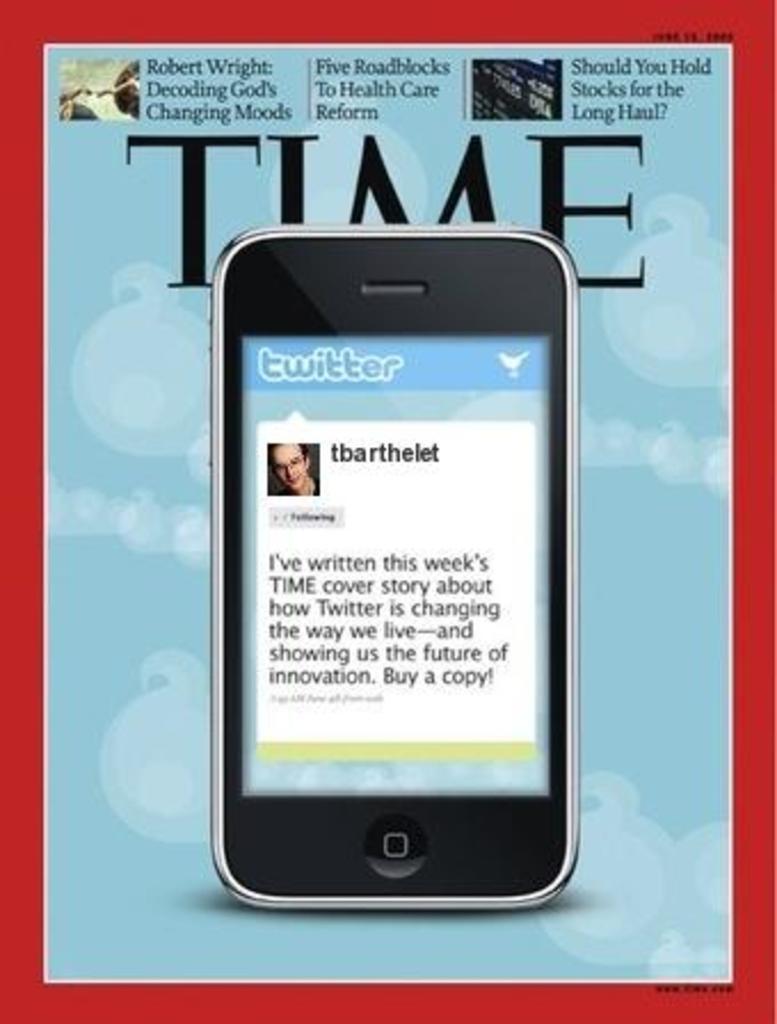What is the magazine name?
Offer a very short reply. Time. What is the twitter username on the phone?
Provide a succinct answer. Tbarthelet. 